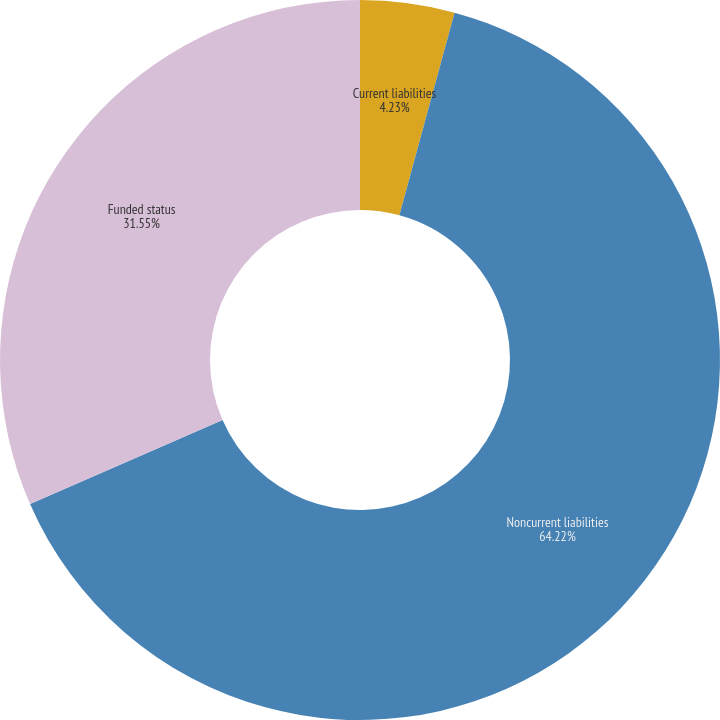Convert chart. <chart><loc_0><loc_0><loc_500><loc_500><pie_chart><fcel>Current liabilities<fcel>Noncurrent liabilities<fcel>Funded status<nl><fcel>4.23%<fcel>64.22%<fcel>31.55%<nl></chart> 